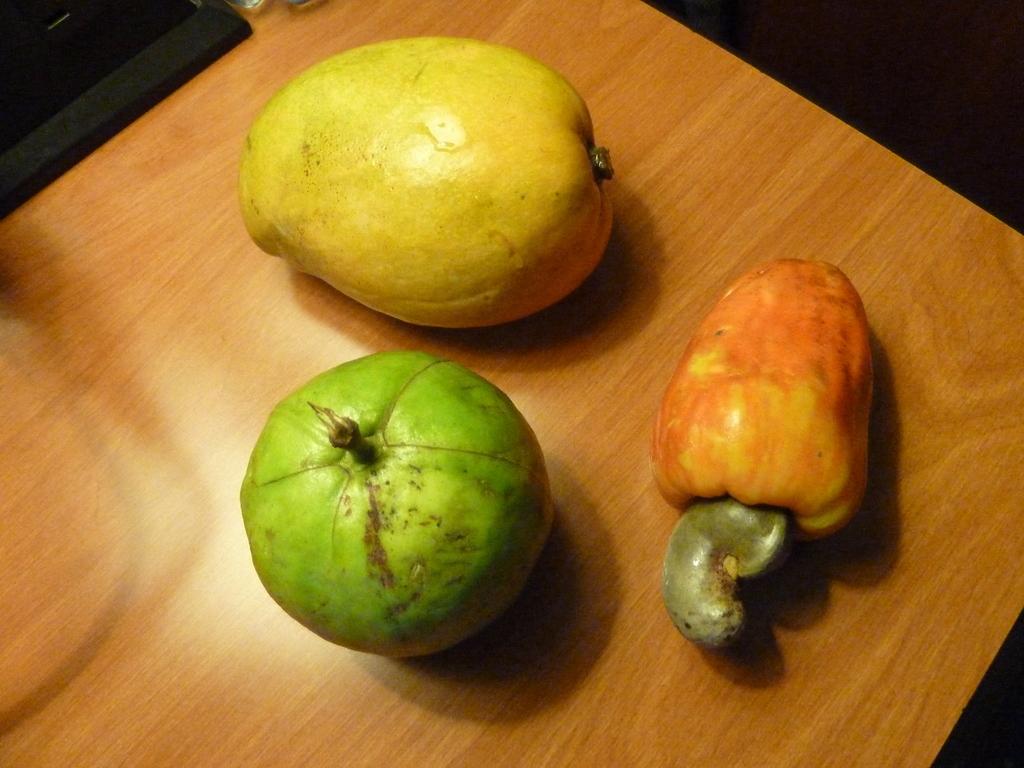Could you give a brief overview of what you see in this image? In this image we can see there are three fruits placed on a wooden surface. 